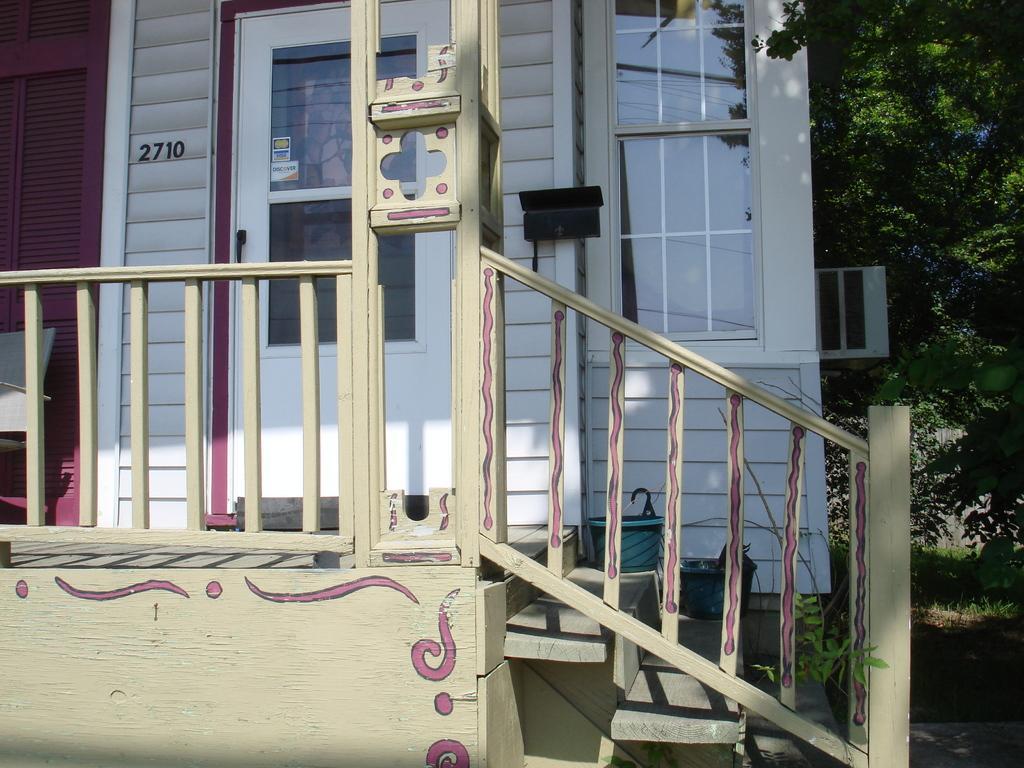Please provide a concise description of this image. In the image in the center we can see one house,door,fence,chair,glass,staircase,wall,plant and few other objects. In the background we can see trees and grass. 